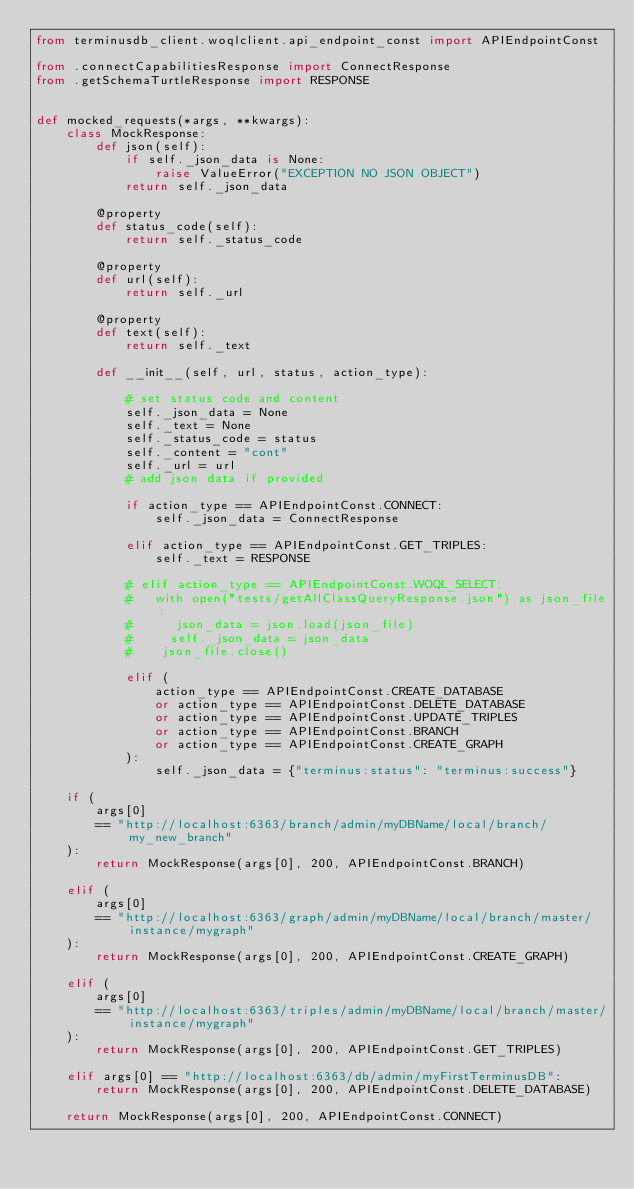Convert code to text. <code><loc_0><loc_0><loc_500><loc_500><_Python_>from terminusdb_client.woqlclient.api_endpoint_const import APIEndpointConst

from .connectCapabilitiesResponse import ConnectResponse
from .getSchemaTurtleResponse import RESPONSE


def mocked_requests(*args, **kwargs):
    class MockResponse:
        def json(self):
            if self._json_data is None:
                raise ValueError("EXCEPTION NO JSON OBJECT")
            return self._json_data

        @property
        def status_code(self):
            return self._status_code

        @property
        def url(self):
            return self._url

        @property
        def text(self):
            return self._text

        def __init__(self, url, status, action_type):

            # set status code and content
            self._json_data = None
            self._text = None
            self._status_code = status
            self._content = "cont"
            self._url = url
            # add json data if provided

            if action_type == APIEndpointConst.CONNECT:
                self._json_data = ConnectResponse

            elif action_type == APIEndpointConst.GET_TRIPLES:
                self._text = RESPONSE

            # elif action_type == APIEndpointConst.WOQL_SELECT:
            #   with open("tests/getAllClassQueryResponse.json") as json_file:
            #      json_data = json.load(json_file)
            #     self._json_data = json_data
            #    json_file.close()

            elif (
                action_type == APIEndpointConst.CREATE_DATABASE
                or action_type == APIEndpointConst.DELETE_DATABASE
                or action_type == APIEndpointConst.UPDATE_TRIPLES
                or action_type == APIEndpointConst.BRANCH
                or action_type == APIEndpointConst.CREATE_GRAPH
            ):
                self._json_data = {"terminus:status": "terminus:success"}

    if (
        args[0]
        == "http://localhost:6363/branch/admin/myDBName/local/branch/my_new_branch"
    ):
        return MockResponse(args[0], 200, APIEndpointConst.BRANCH)

    elif (
        args[0]
        == "http://localhost:6363/graph/admin/myDBName/local/branch/master/instance/mygraph"
    ):
        return MockResponse(args[0], 200, APIEndpointConst.CREATE_GRAPH)

    elif (
        args[0]
        == "http://localhost:6363/triples/admin/myDBName/local/branch/master/instance/mygraph"
    ):
        return MockResponse(args[0], 200, APIEndpointConst.GET_TRIPLES)

    elif args[0] == "http://localhost:6363/db/admin/myFirstTerminusDB":
        return MockResponse(args[0], 200, APIEndpointConst.DELETE_DATABASE)

    return MockResponse(args[0], 200, APIEndpointConst.CONNECT)
</code> 